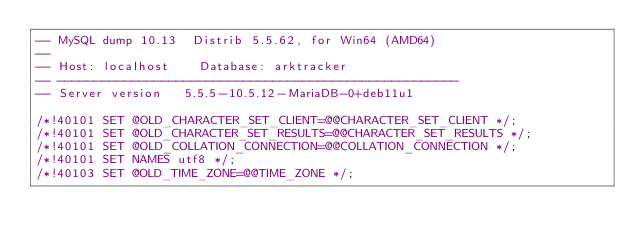Convert code to text. <code><loc_0><loc_0><loc_500><loc_500><_SQL_>-- MySQL dump 10.13  Distrib 5.5.62, for Win64 (AMD64)
--
-- Host: localhost    Database: arktracker
-- ------------------------------------------------------
-- Server version	5.5.5-10.5.12-MariaDB-0+deb11u1

/*!40101 SET @OLD_CHARACTER_SET_CLIENT=@@CHARACTER_SET_CLIENT */;
/*!40101 SET @OLD_CHARACTER_SET_RESULTS=@@CHARACTER_SET_RESULTS */;
/*!40101 SET @OLD_COLLATION_CONNECTION=@@COLLATION_CONNECTION */;
/*!40101 SET NAMES utf8 */;
/*!40103 SET @OLD_TIME_ZONE=@@TIME_ZONE */;</code> 